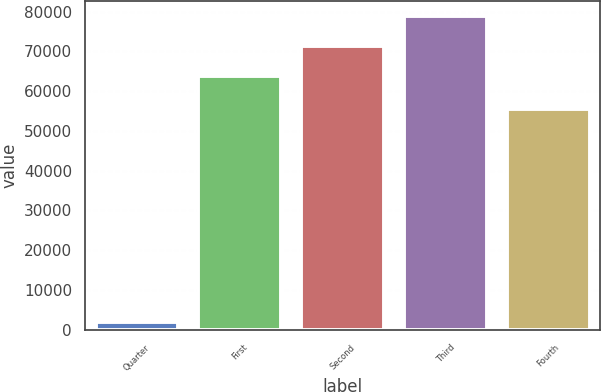Convert chart. <chart><loc_0><loc_0><loc_500><loc_500><bar_chart><fcel>Quarter<fcel>First<fcel>Second<fcel>Third<fcel>Fourth<nl><fcel>2010<fcel>63789<fcel>71291.8<fcel>78794.6<fcel>55578<nl></chart> 